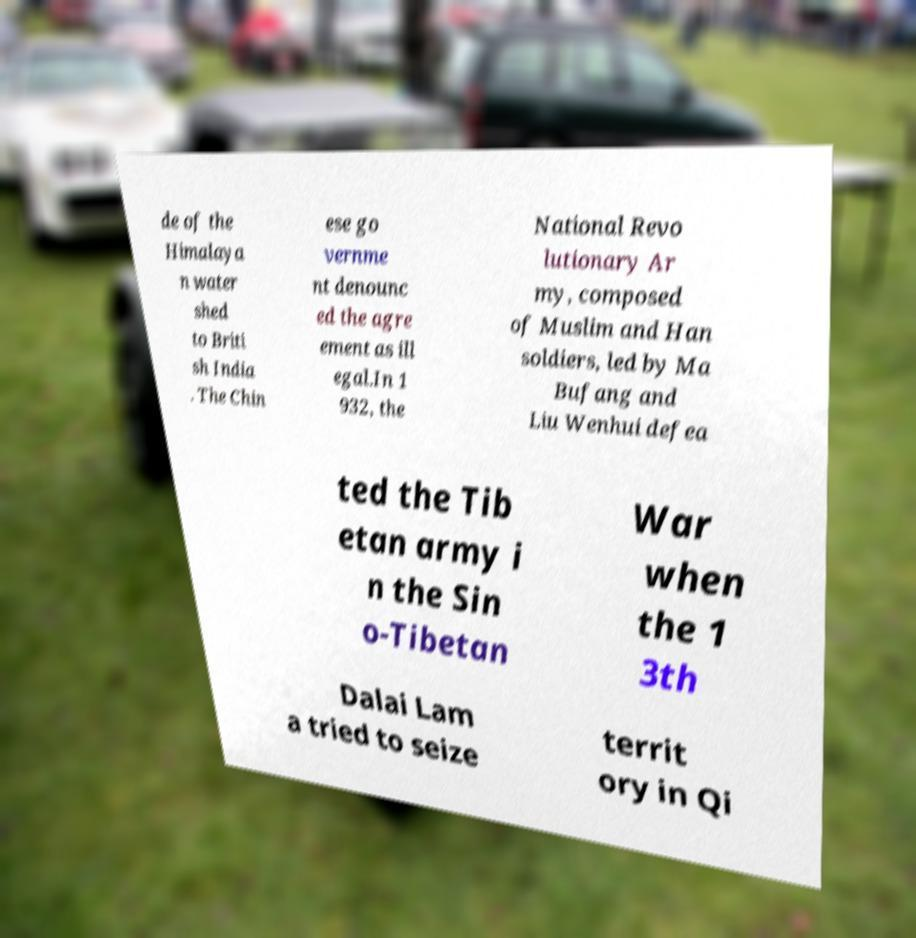Can you accurately transcribe the text from the provided image for me? de of the Himalaya n water shed to Briti sh India . The Chin ese go vernme nt denounc ed the agre ement as ill egal.In 1 932, the National Revo lutionary Ar my, composed of Muslim and Han soldiers, led by Ma Bufang and Liu Wenhui defea ted the Tib etan army i n the Sin o-Tibetan War when the 1 3th Dalai Lam a tried to seize territ ory in Qi 